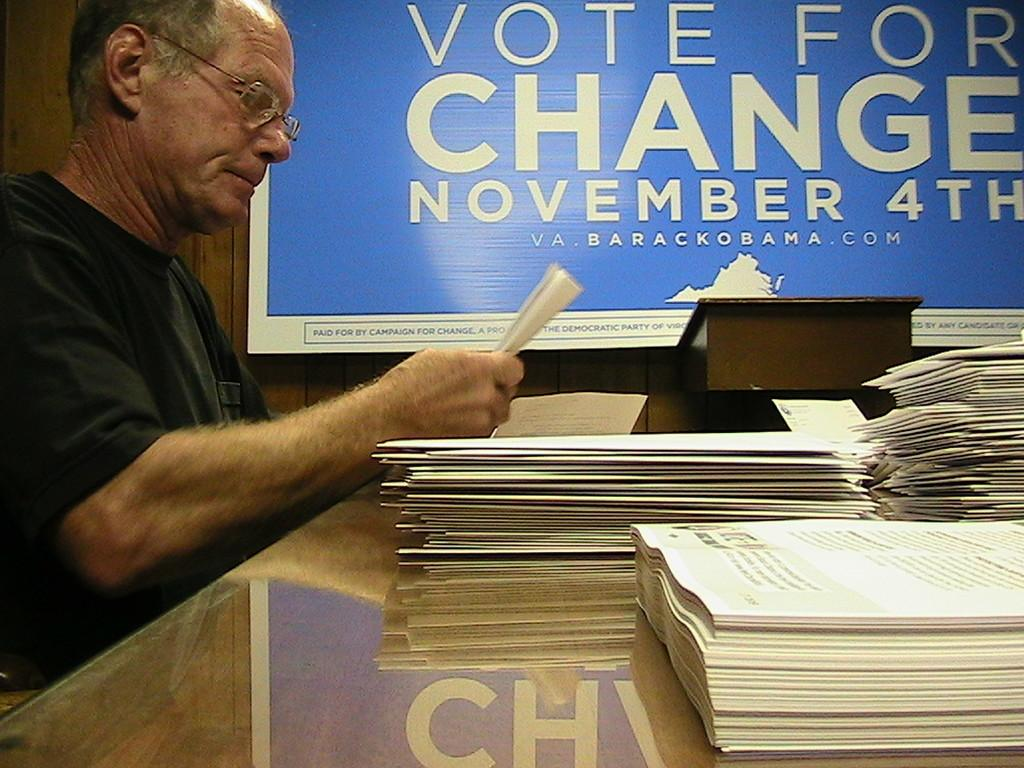Provide a one-sentence caption for the provided image. A man looks at papers in front of a Vote for Change sign. 